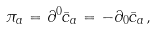<formula> <loc_0><loc_0><loc_500><loc_500>\pi _ { a } = \partial ^ { 0 } { \bar { c } } _ { a } = - \partial _ { 0 } { \bar { c } } _ { a } ,</formula> 